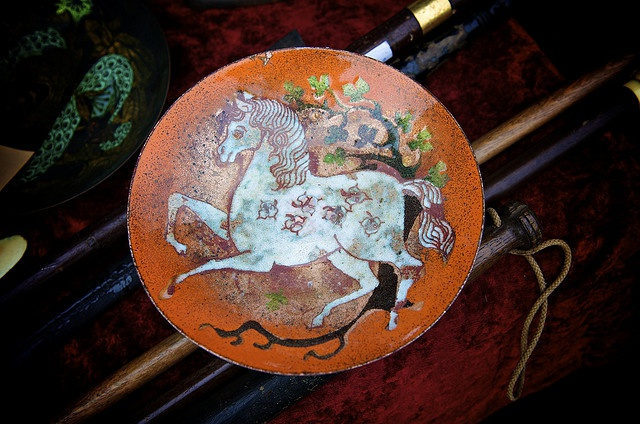Describe the objects in this image and their specific colors. I can see a horse in black, lightgray, lightblue, darkgray, and gray tones in this image. 